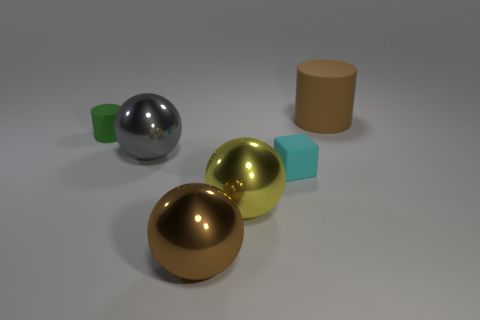Add 2 tiny cyan metallic cylinders. How many objects exist? 8 Subtract all cylinders. How many objects are left? 4 Subtract 2 spheres. How many spheres are left? 1 Subtract all gray cylinders. Subtract all blue blocks. How many cylinders are left? 2 Subtract all purple blocks. How many purple spheres are left? 0 Subtract all big brown cylinders. Subtract all large brown matte cylinders. How many objects are left? 4 Add 6 green rubber objects. How many green rubber objects are left? 7 Add 6 brown rubber cylinders. How many brown rubber cylinders exist? 7 Subtract all yellow balls. How many balls are left? 2 Subtract 0 cyan cylinders. How many objects are left? 6 